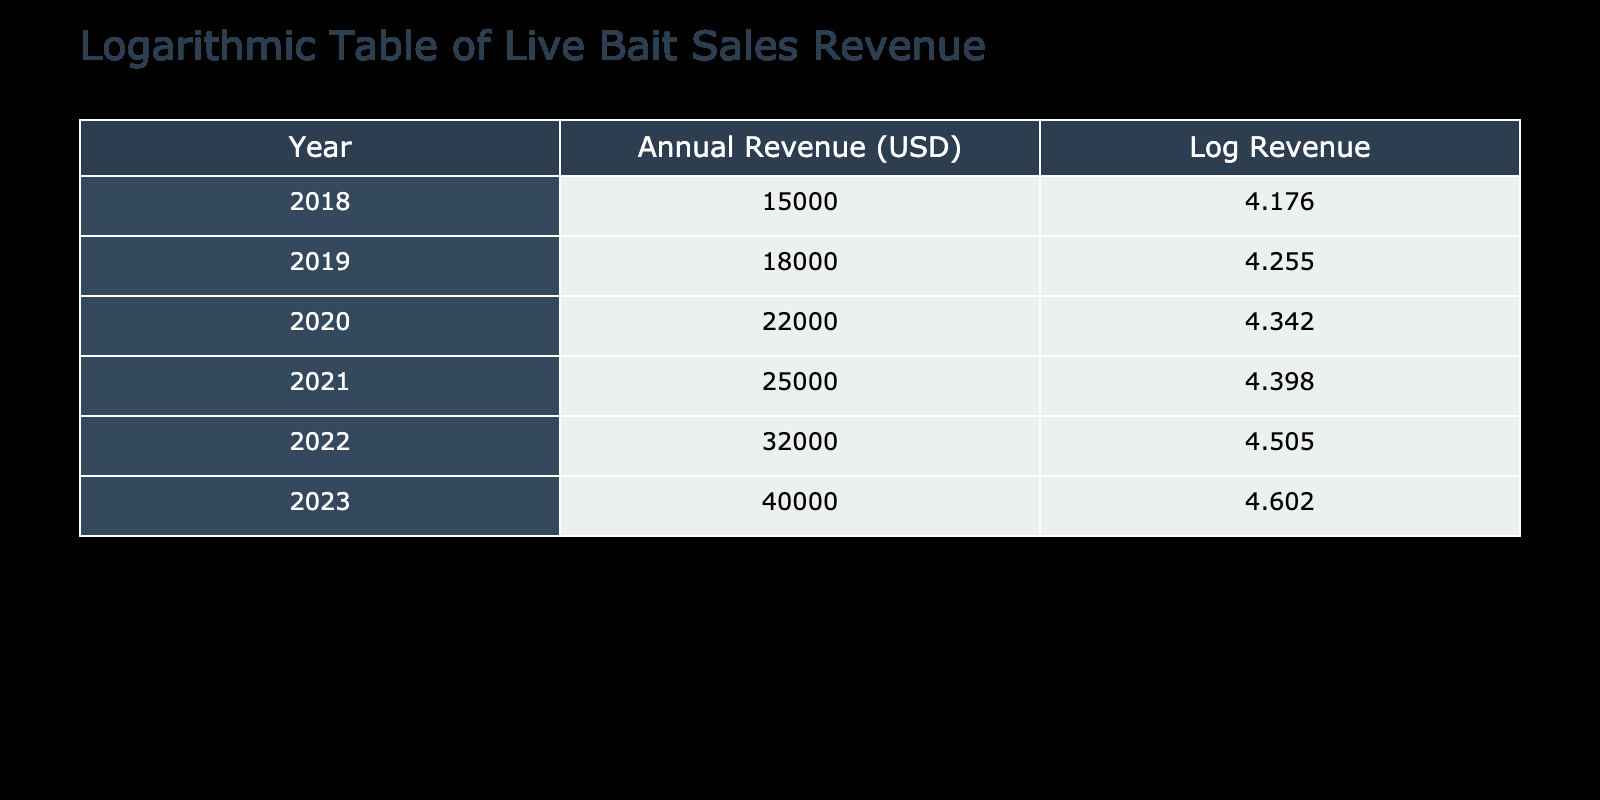What was the annual revenue from live bait sales in 2020? In the table, under the 'Annual Revenue from Live Bait Sales (USD)' column for the year 2020, the value is listed as 22000.
Answer: 22000 What is the log revenue for the year 2021? Looking at the 'Log Revenue' column for the year 2021, the value is calculated as log10(25000), which rounds to 4.398.
Answer: 4.398 Which year had the highest annual revenue from live bait sales? By checking the 'Annual Revenue from Live Bait Sales (USD)' column, we see that 2023 has the highest value at 40000.
Answer: 2023 What is the total annual revenue from live bait sales from 2018 to 2022? We sum the revenue from each year: 15000 (2018) + 18000 (2019) + 22000 (2020) + 25000 (2021) + 32000 (2022) = 112000.
Answer: 112000 Was the revenue in 2019 greater than the average revenue from 2018 to 2023? First, we calculate the average revenue: (15000 + 18000 + 22000 + 25000 + 32000 + 40000) / 6 = 22000. Since 2019's revenue of 18000 is less than 22000, the answer is no.
Answer: No If we compare the revenue from 2022 to 2023, how much more was earned in 2023? Subtract the revenue of 2022 from that of 2023: 40000 (2023) - 32000 (2022) = 8000. So there was an increase of 8000 in 2023 compared to 2022.
Answer: 8000 Is it true that the log revenue for 2022 is less than that of 2023? Checking the log revenues: log10(32000) for 2022 is approximately 4.505 and log10(40000) for 2023 is approximately 4.602. Since 4.505 is less than 4.602, the statement is true.
Answer: Yes What was the percentage increase in annual revenue from 2018 to 2023? The revenue increased from 15000 in 2018 to 40000 in 2023. Percentage increase = [(40000 - 15000) / 15000] * 100 = 166.67%.
Answer: 166.67% How many years saw a revenue greater than 20000? Checking each year's revenue: 22000 (2020), 25000 (2021), 32000 (2022), and 40000 (2023) are greater than 20000, which totals to 4 years.
Answer: 4 